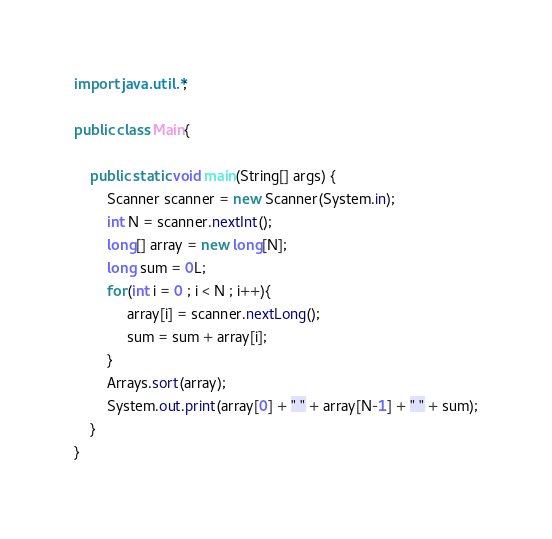Convert code to text. <code><loc_0><loc_0><loc_500><loc_500><_Java_>import java.util.*;

public class Main{

	public static void main(String[] args) {
		Scanner scanner = new Scanner(System.in);
		int N = scanner.nextInt();
		long[] array = new long[N];
		long sum = 0L;
		for(int i = 0 ; i < N ; i++){
			 array[i] = scanner.nextLong();
			 sum = sum + array[i];
		}
		Arrays.sort(array);
		System.out.print(array[0] + " " + array[N-1] + " " + sum);
	}
}</code> 